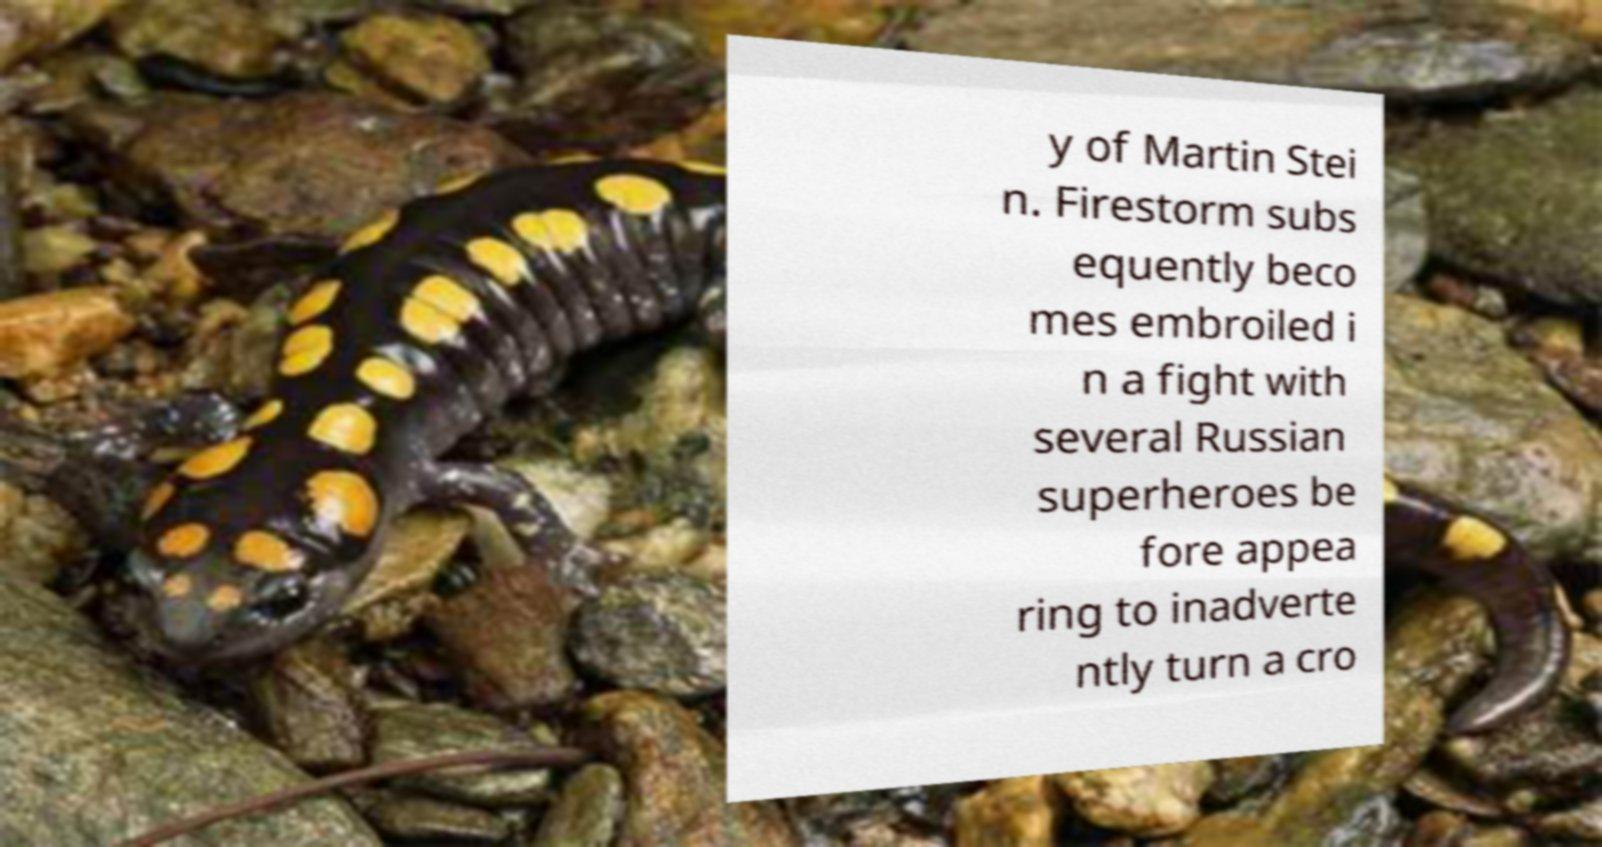Can you read and provide the text displayed in the image?This photo seems to have some interesting text. Can you extract and type it out for me? y of Martin Stei n. Firestorm subs equently beco mes embroiled i n a fight with several Russian superheroes be fore appea ring to inadverte ntly turn a cro 